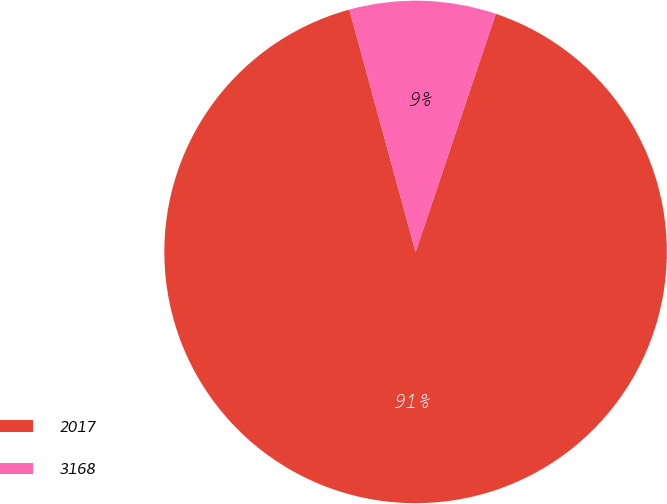<chart> <loc_0><loc_0><loc_500><loc_500><pie_chart><fcel>2017<fcel>3168<nl><fcel>90.58%<fcel>9.42%<nl></chart> 